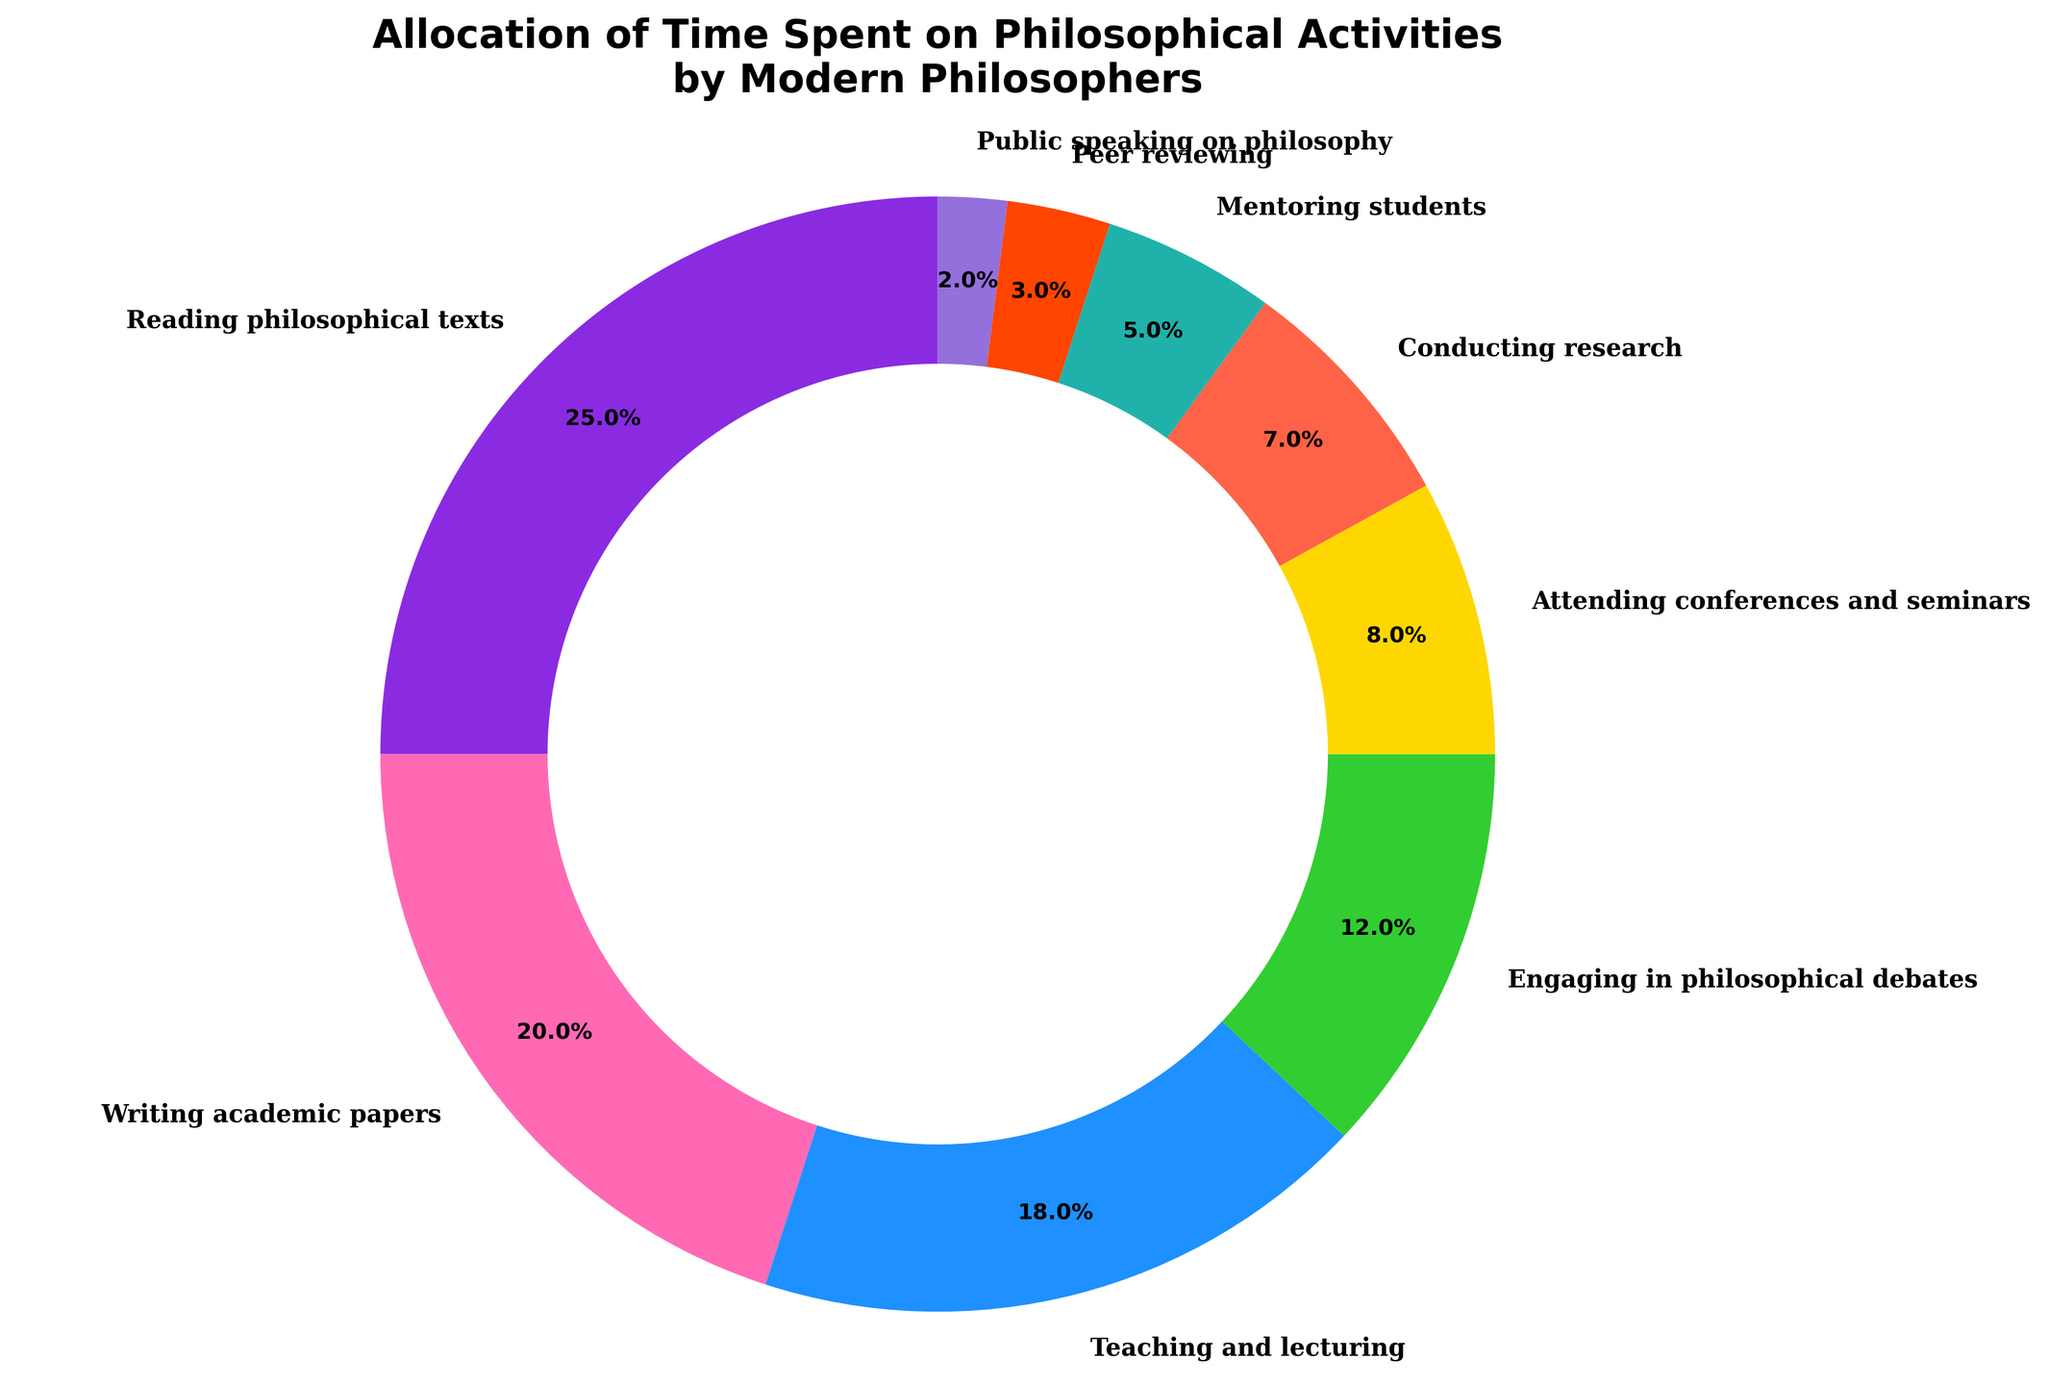What is the most time-consuming activity for modern philosophers? The slice that occupies the largest portion of the pie chart is labeled "Reading philosophical texts" with 25%.
Answer: Reading philosophical texts Which activities together make up more than half of the pie chart? Summing the percentages of the highest activities: "Reading philosophical texts" (25%), "Writing academic papers" (20%), and "Teaching and lecturing" (18%). Together these activities contribute 25% + 20% + 18% = 63%.
Answer: Reading philosophical texts, Writing academic papers, Teaching and lecturing How much time is spent on activities related to engaging with others (debating, attending conferences, mentoring, etc.)? The relevant activities and their percentages are: "Engaging in philosophical debates" (12%), "Attending conferences and seminars" (8%), "Mentoring students" (5%), "Public speaking on philosophy" (2%), and "Peer reviewing" (3%). Adding these gives: 12% + 8% + 5% + 2% + 3% = 30%.
Answer: 30% Is more time spent teaching and lecturing or conducting research? "Teaching and lecturing" is 18%, whereas "Conducting research" is 7%. Comparatively, more time is spent on teaching and lecturing.
Answer: Teaching and lecturing What is the difference in time allocation between peer reviewing and public speaking? "Peer reviewing" is allocated 3%, and "Public speaking on philosophy" is allocated 2%. The difference is computed by 3% - 2% = 1%.
Answer: 1% Which visual attribute indicates the activity with the least time spent? The activity with the smallest slice in the pie chart is "Public speaking on philosophy" with 2%, indicated by its minimal size compared to other slices.
Answer: Public speaking on philosophy What percentage of time do modern philosophers spend on academic activities (writing papers, conducting research, peer reviewing)? The relevant activities and their percentages are: "Writing academic papers" (20%), "Conducting research" (7%), "Peer reviewing" (3%). Summing these values gives: 20% + 7% + 3% = 30%.
Answer: 30% Among teaching and researching activities, which is allocated more time, and by how much? "Teaching and lecturing" is 18%, while "Conducting research" is 7%. The difference is calculated by 18% - 7% = 11%.
Answer: Teaching and lecturing by 11% 